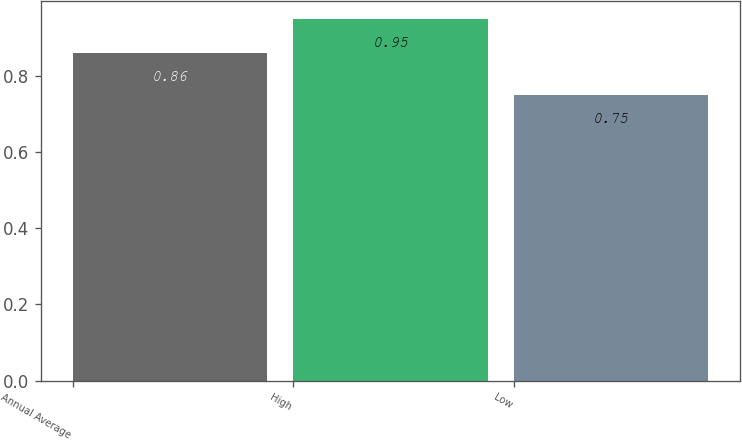<chart> <loc_0><loc_0><loc_500><loc_500><bar_chart><fcel>Annual Average<fcel>High<fcel>Low<nl><fcel>0.86<fcel>0.95<fcel>0.75<nl></chart> 